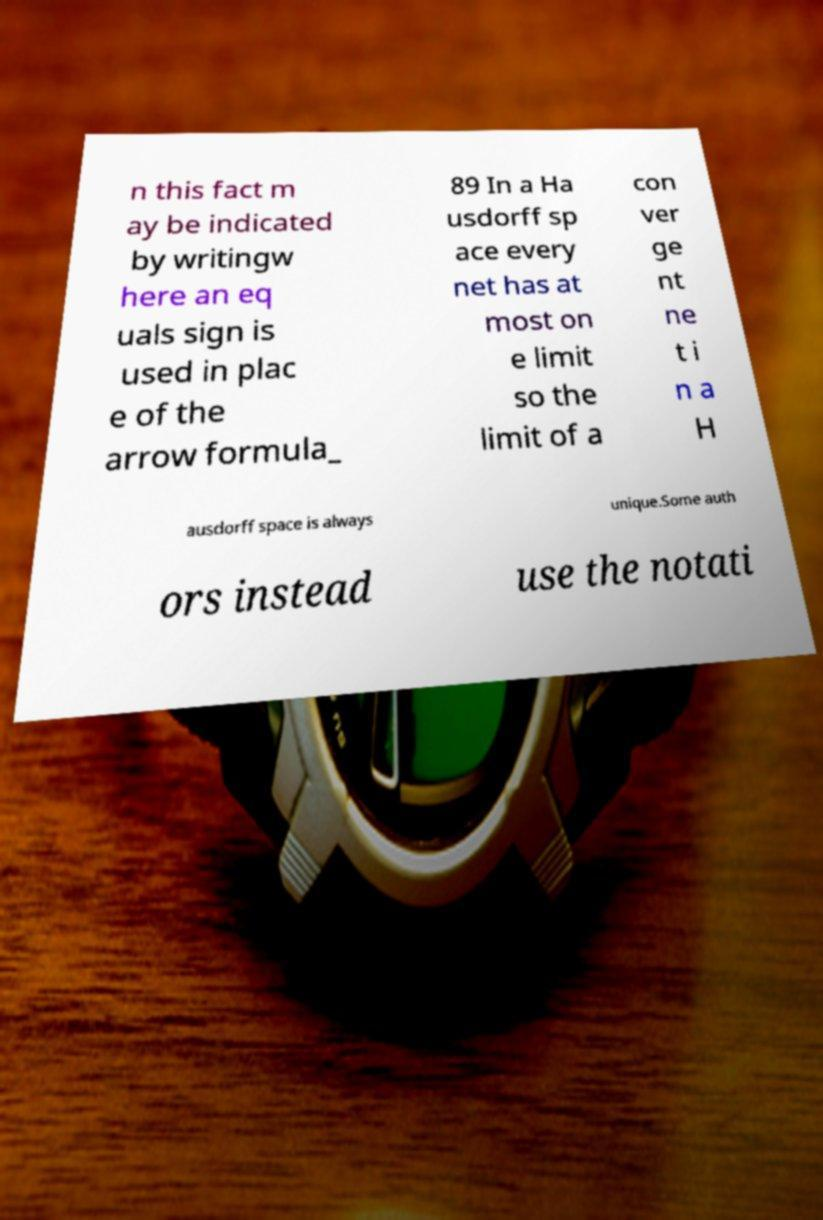Can you read and provide the text displayed in the image?This photo seems to have some interesting text. Can you extract and type it out for me? n this fact m ay be indicated by writingw here an eq uals sign is used in plac e of the arrow formula_ 89 In a Ha usdorff sp ace every net has at most on e limit so the limit of a con ver ge nt ne t i n a H ausdorff space is always unique.Some auth ors instead use the notati 